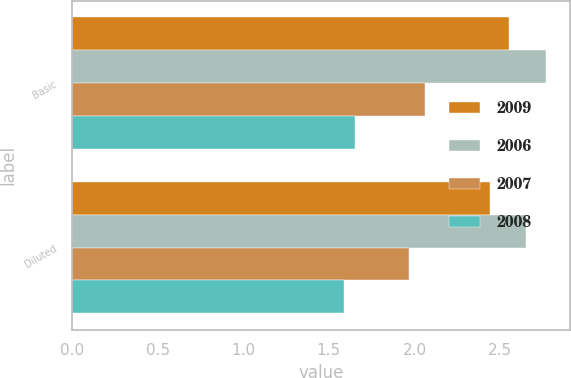<chart> <loc_0><loc_0><loc_500><loc_500><stacked_bar_chart><ecel><fcel>Basic<fcel>Diluted<nl><fcel>2009<fcel>2.55<fcel>2.44<nl><fcel>2006<fcel>2.77<fcel>2.65<nl><fcel>2007<fcel>2.06<fcel>1.97<nl><fcel>2008<fcel>1.65<fcel>1.59<nl></chart> 